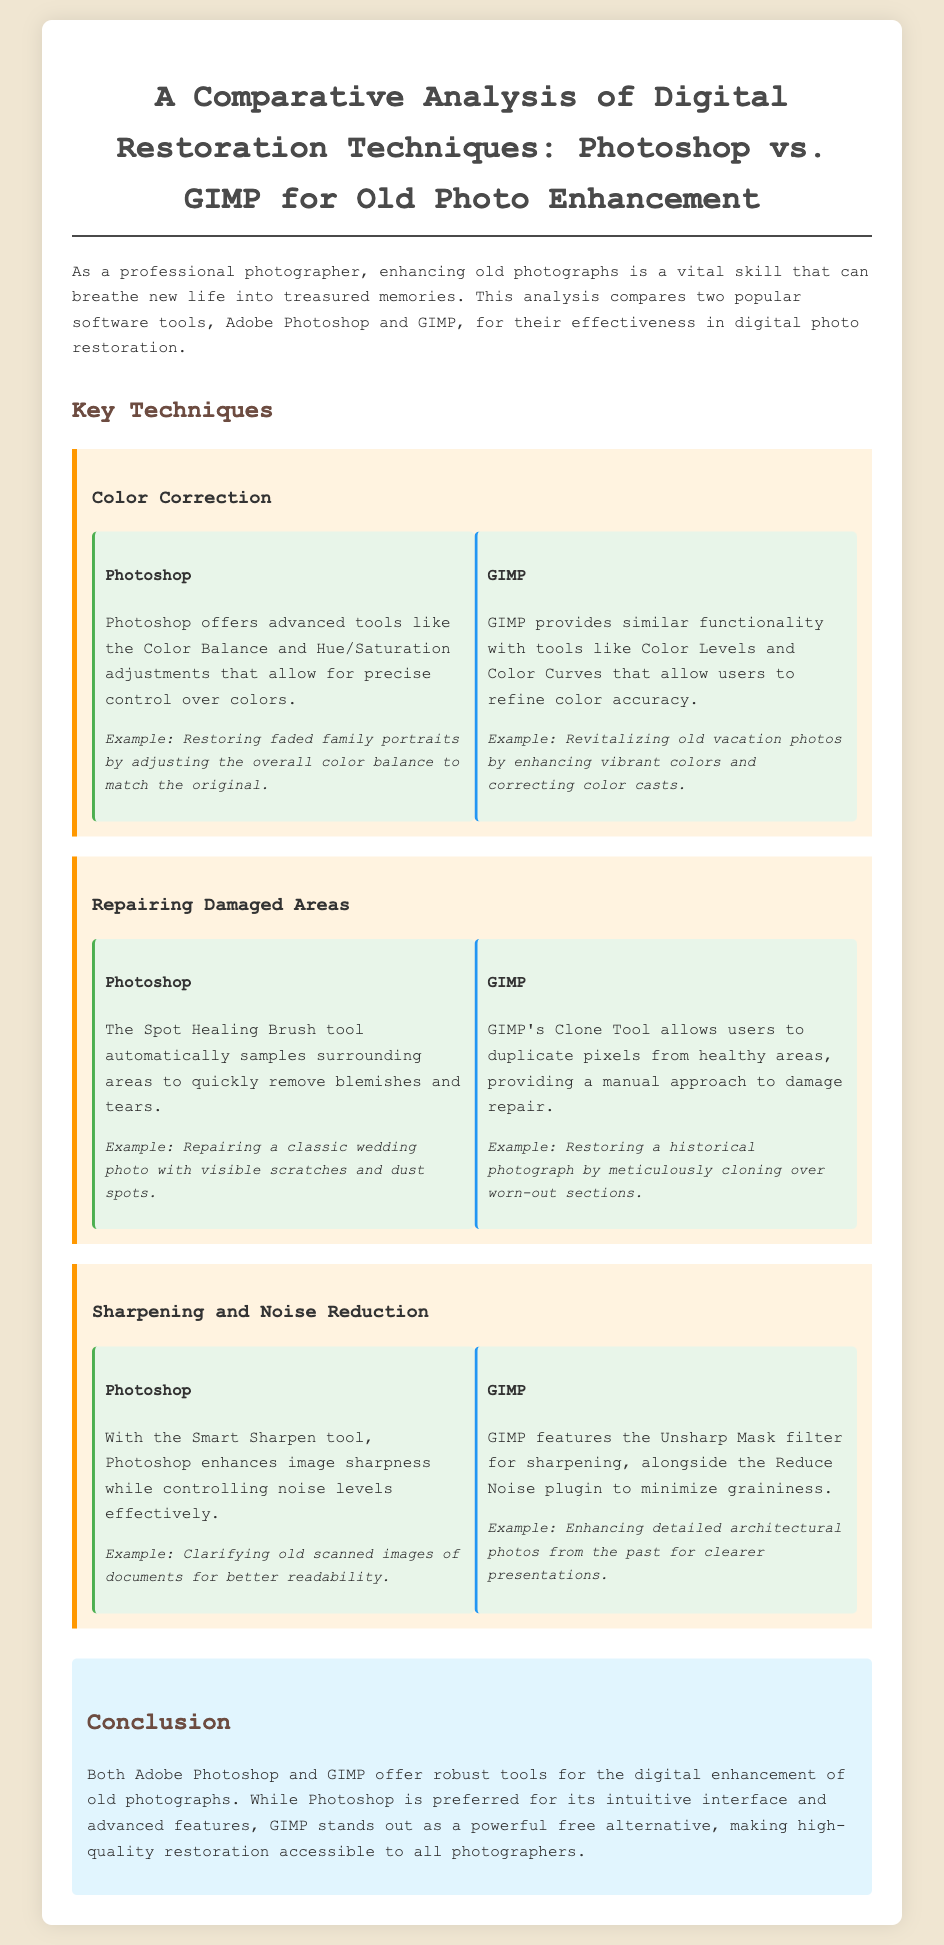What is the main purpose of the document? The document provides a comparative analysis of digital restoration techniques for enhancing old photographs using Photoshop and GIMP.
Answer: Comparative analysis of digital restoration techniques Which tool offers the Spot Healing Brush? The Spot Healing Brush is a tool in Adobe Photoshop that automates damage repair.
Answer: Adobe Photoshop What example is given for using GIMP's Clone Tool? The example provided is restoring a historical photograph by cloning over worn-out sections.
Answer: Restoring a historical photograph What technique is used for sharpening in GIMP? GIMP uses the Unsharp Mask filter for sharpening images.
Answer: Unsharp Mask filter What conclusion is drawn about Photoshop's interface? The conclusion states that Photoshop is preferred for its intuitive interface.
Answer: Intuitive interface Which technique focuses on color accuracy? Color Correction is the technique that focuses on color accuracy.
Answer: Color Correction What are the main tools discussed in the color correction section? The main tools discussed are Color Balance and Hue/Saturation for Photoshop, and Color Levels and Color Curves for GIMP.
Answer: Color Balance, Hue/Saturation, Color Levels, Color Curves How does GIMP compare in terms of cost? GIMP is a free alternative for photo restoration compared to Photoshop.
Answer: Free alternative 